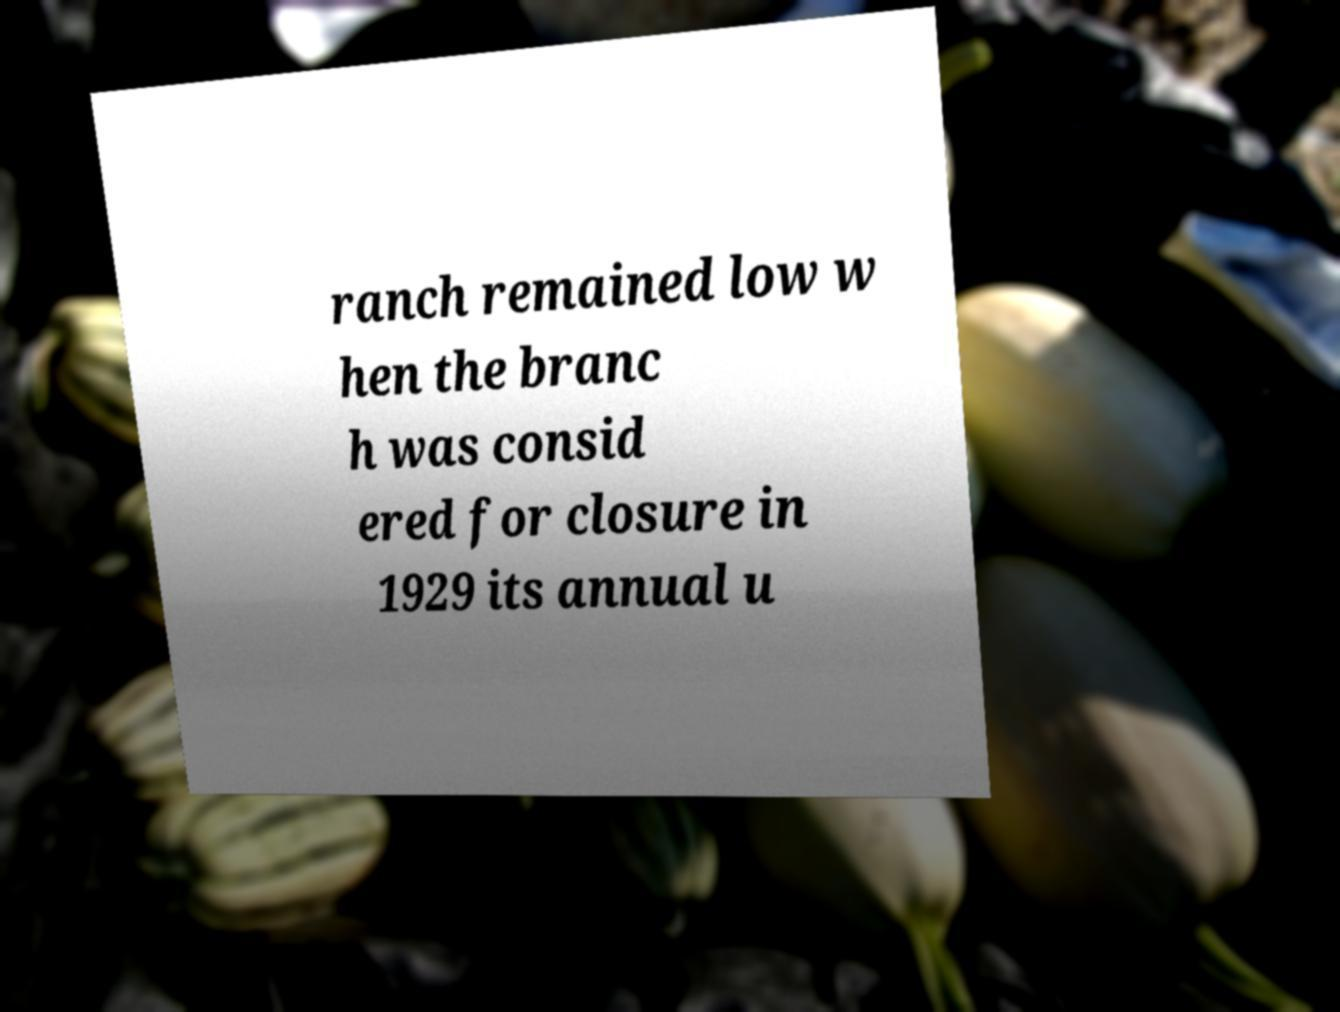What messages or text are displayed in this image? I need them in a readable, typed format. ranch remained low w hen the branc h was consid ered for closure in 1929 its annual u 